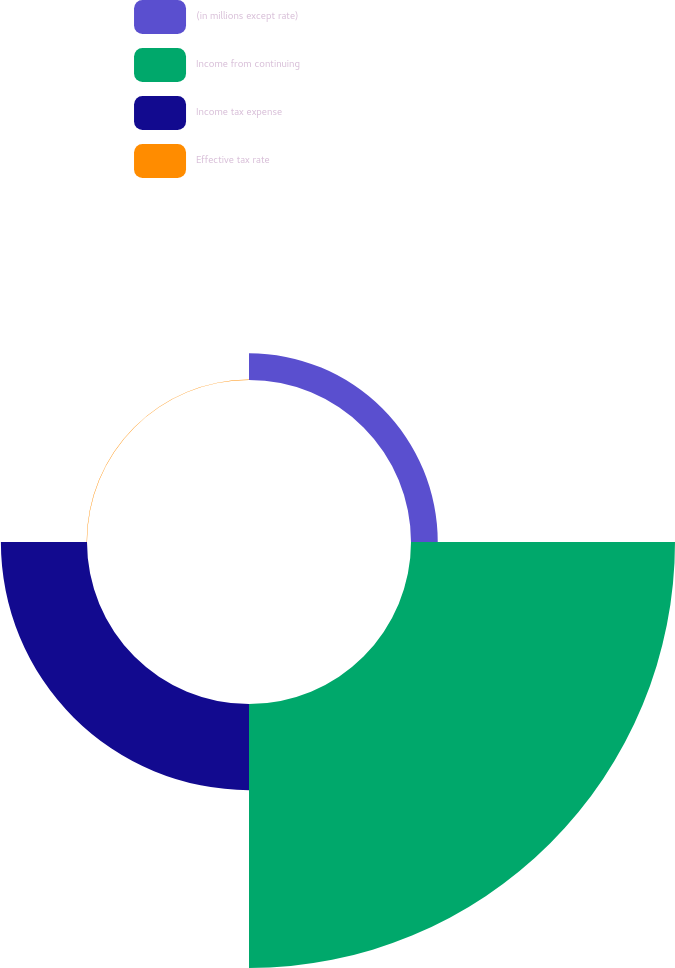<chart> <loc_0><loc_0><loc_500><loc_500><pie_chart><fcel>(in millions except rate)<fcel>Income from continuing<fcel>Income tax expense<fcel>Effective tax rate<nl><fcel>7.09%<fcel>69.98%<fcel>22.83%<fcel>0.1%<nl></chart> 